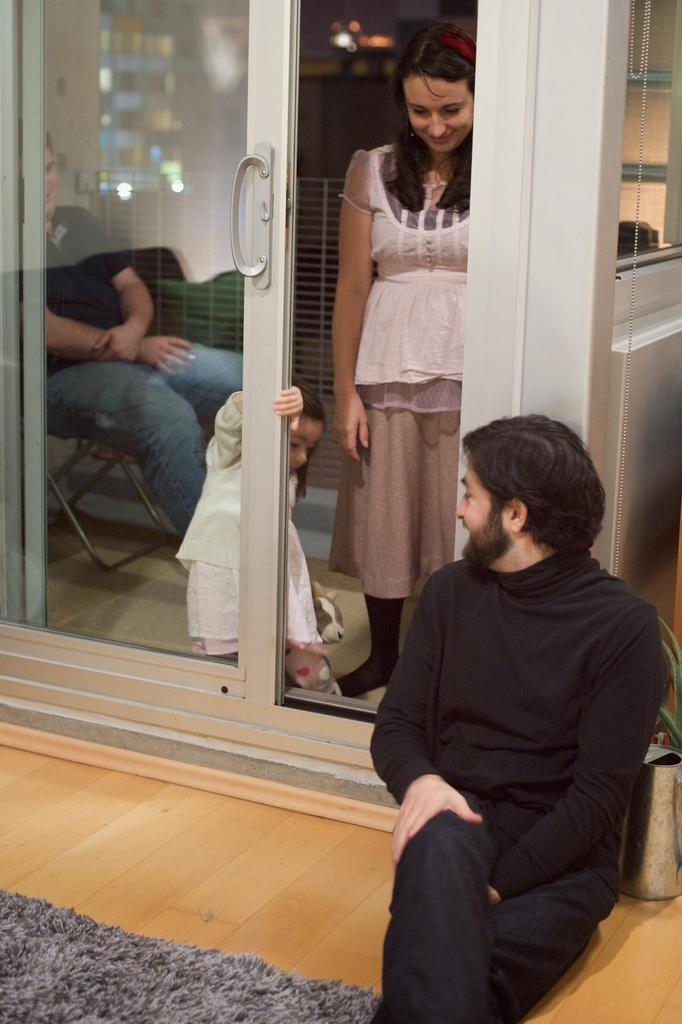Who or what can be seen in the image? There are people in the image. What type of architectural feature is present in the image? There is a glass door and a window in the image. What is visible on the ground in the image? The ground is visible in the image. What type of material is present in the image? There is a cloth in the image. What type of object is present in the image? There is a toy in the image. Where is the object located in the image? There is an object on the right side of the image. How many flocks of birds can be seen flying through the window in the image? There are no flocks of birds visible in the image; only people, a glass door, a window, the ground, a cloth, a toy, and an object are present. 